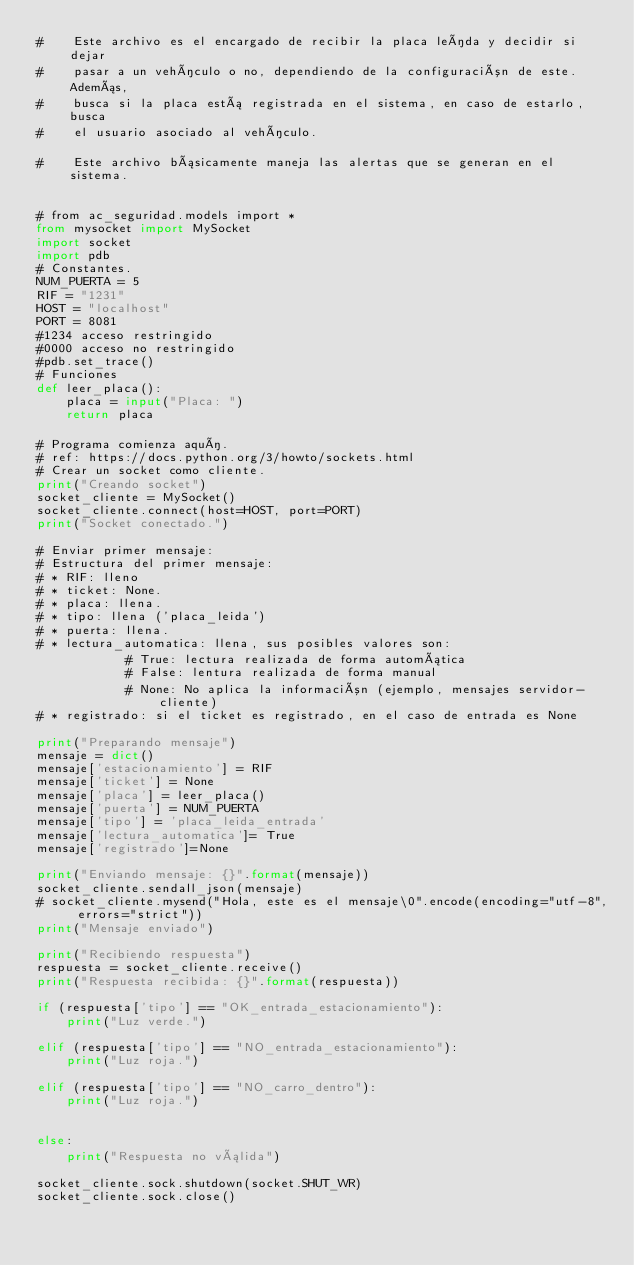Convert code to text. <code><loc_0><loc_0><loc_500><loc_500><_Python_>#    Este archivo es el encargado de recibir la placa leída y decidir si dejar
#    pasar a un vehículo o no, dependiendo de la configuración de este. Además,
#    busca si la placa está registrada en el sistema, en caso de estarlo, busca
#    el usuario asociado al vehículo.

#    Este archivo básicamente maneja las alertas que se generan en el sistema.


# from ac_seguridad.models import *
from mysocket import MySocket
import socket
import pdb
# Constantes.
NUM_PUERTA = 5
RIF = "1231"
HOST = "localhost"
PORT = 8081
#1234 acceso restringido
#0000 acceso no restringido
#pdb.set_trace()
# Funciones
def leer_placa():
    placa = input("Placa: ")
    return placa

# Programa comienza aquí.
# ref: https://docs.python.org/3/howto/sockets.html
# Crear un socket como cliente.
print("Creando socket")
socket_cliente = MySocket()
socket_cliente.connect(host=HOST, port=PORT)
print("Socket conectado.")

# Enviar primer mensaje:
# Estructura del primer mensaje:
# * RIF: lleno
# * ticket: None.
# * placa: llena.
# * tipo: llena ('placa_leida')
# * puerta: llena.
# * lectura_automatica: llena, sus posibles valores son:
            # True: lectura realizada de forma automática
            # False: lentura realizada de forma manual
            # None: No aplica la información (ejemplo, mensajes servidor-cliente)
# * registrado: si el ticket es registrado, en el caso de entrada es None

print("Preparando mensaje")
mensaje = dict()
mensaje['estacionamiento'] = RIF
mensaje['ticket'] = None
mensaje['placa'] = leer_placa()
mensaje['puerta'] = NUM_PUERTA
mensaje['tipo'] = 'placa_leida_entrada'
mensaje['lectura_automatica']= True
mensaje['registrado']=None

print("Enviando mensaje: {}".format(mensaje))
socket_cliente.sendall_json(mensaje)
# socket_cliente.mysend("Hola, este es el mensaje\0".encode(encoding="utf-8", errors="strict"))
print("Mensaje enviado")

print("Recibiendo respuesta")
respuesta = socket_cliente.receive()
print("Respuesta recibida: {}".format(respuesta))

if (respuesta['tipo'] == "OK_entrada_estacionamiento"):
    print("Luz verde.")

elif (respuesta['tipo'] == "NO_entrada_estacionamiento"):
    print("Luz roja.")

elif (respuesta['tipo'] == "NO_carro_dentro"):
    print("Luz roja.")


else:
    print("Respuesta no válida")

socket_cliente.sock.shutdown(socket.SHUT_WR)
socket_cliente.sock.close()
</code> 